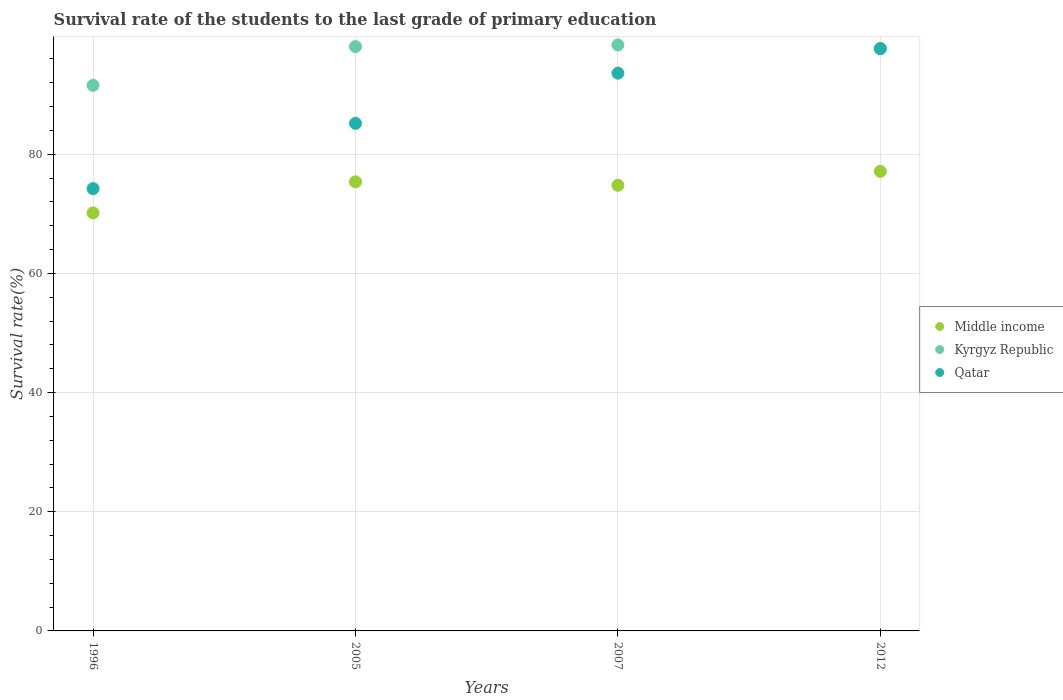How many different coloured dotlines are there?
Keep it short and to the point. 3. Is the number of dotlines equal to the number of legend labels?
Offer a terse response. Yes. What is the survival rate of the students in Kyrgyz Republic in 2012?
Provide a succinct answer. 97.74. Across all years, what is the maximum survival rate of the students in Kyrgyz Republic?
Provide a short and direct response. 98.35. Across all years, what is the minimum survival rate of the students in Qatar?
Your answer should be compact. 74.24. In which year was the survival rate of the students in Middle income minimum?
Your response must be concise. 1996. What is the total survival rate of the students in Middle income in the graph?
Provide a succinct answer. 297.47. What is the difference between the survival rate of the students in Kyrgyz Republic in 2007 and that in 2012?
Ensure brevity in your answer.  0.6. What is the difference between the survival rate of the students in Qatar in 2012 and the survival rate of the students in Kyrgyz Republic in 2007?
Your answer should be compact. -0.61. What is the average survival rate of the students in Qatar per year?
Provide a short and direct response. 87.7. In the year 2007, what is the difference between the survival rate of the students in Qatar and survival rate of the students in Kyrgyz Republic?
Provide a short and direct response. -4.73. In how many years, is the survival rate of the students in Qatar greater than 8 %?
Make the answer very short. 4. What is the ratio of the survival rate of the students in Kyrgyz Republic in 2005 to that in 2012?
Provide a succinct answer. 1. Is the difference between the survival rate of the students in Qatar in 1996 and 2005 greater than the difference between the survival rate of the students in Kyrgyz Republic in 1996 and 2005?
Your answer should be compact. No. What is the difference between the highest and the second highest survival rate of the students in Qatar?
Your response must be concise. 4.13. What is the difference between the highest and the lowest survival rate of the students in Kyrgyz Republic?
Make the answer very short. 6.78. In how many years, is the survival rate of the students in Kyrgyz Republic greater than the average survival rate of the students in Kyrgyz Republic taken over all years?
Your answer should be compact. 3. Does the survival rate of the students in Kyrgyz Republic monotonically increase over the years?
Provide a succinct answer. No. Is the survival rate of the students in Middle income strictly greater than the survival rate of the students in Kyrgyz Republic over the years?
Provide a succinct answer. No. How many dotlines are there?
Offer a very short reply. 3. How many years are there in the graph?
Give a very brief answer. 4. What is the difference between two consecutive major ticks on the Y-axis?
Provide a succinct answer. 20. Does the graph contain any zero values?
Make the answer very short. No. What is the title of the graph?
Provide a short and direct response. Survival rate of the students to the last grade of primary education. Does "Ireland" appear as one of the legend labels in the graph?
Keep it short and to the point. No. What is the label or title of the X-axis?
Keep it short and to the point. Years. What is the label or title of the Y-axis?
Make the answer very short. Survival rate(%). What is the Survival rate(%) in Middle income in 1996?
Make the answer very short. 70.16. What is the Survival rate(%) in Kyrgyz Republic in 1996?
Provide a short and direct response. 91.57. What is the Survival rate(%) of Qatar in 1996?
Ensure brevity in your answer.  74.24. What is the Survival rate(%) in Middle income in 2005?
Your response must be concise. 75.38. What is the Survival rate(%) in Kyrgyz Republic in 2005?
Make the answer very short. 98.08. What is the Survival rate(%) in Qatar in 2005?
Your answer should be compact. 85.19. What is the Survival rate(%) in Middle income in 2007?
Your answer should be compact. 74.79. What is the Survival rate(%) of Kyrgyz Republic in 2007?
Provide a succinct answer. 98.35. What is the Survival rate(%) in Qatar in 2007?
Your response must be concise. 93.61. What is the Survival rate(%) in Middle income in 2012?
Ensure brevity in your answer.  77.14. What is the Survival rate(%) in Kyrgyz Republic in 2012?
Your answer should be very brief. 97.74. What is the Survival rate(%) in Qatar in 2012?
Your answer should be compact. 97.74. Across all years, what is the maximum Survival rate(%) in Middle income?
Offer a very short reply. 77.14. Across all years, what is the maximum Survival rate(%) in Kyrgyz Republic?
Your response must be concise. 98.35. Across all years, what is the maximum Survival rate(%) in Qatar?
Offer a very short reply. 97.74. Across all years, what is the minimum Survival rate(%) of Middle income?
Your answer should be very brief. 70.16. Across all years, what is the minimum Survival rate(%) of Kyrgyz Republic?
Ensure brevity in your answer.  91.57. Across all years, what is the minimum Survival rate(%) in Qatar?
Offer a terse response. 74.24. What is the total Survival rate(%) in Middle income in the graph?
Keep it short and to the point. 297.47. What is the total Survival rate(%) of Kyrgyz Republic in the graph?
Your answer should be compact. 385.74. What is the total Survival rate(%) of Qatar in the graph?
Offer a very short reply. 350.78. What is the difference between the Survival rate(%) of Middle income in 1996 and that in 2005?
Make the answer very short. -5.21. What is the difference between the Survival rate(%) in Kyrgyz Republic in 1996 and that in 2005?
Keep it short and to the point. -6.51. What is the difference between the Survival rate(%) in Qatar in 1996 and that in 2005?
Give a very brief answer. -10.95. What is the difference between the Survival rate(%) of Middle income in 1996 and that in 2007?
Keep it short and to the point. -4.62. What is the difference between the Survival rate(%) of Kyrgyz Republic in 1996 and that in 2007?
Make the answer very short. -6.78. What is the difference between the Survival rate(%) in Qatar in 1996 and that in 2007?
Keep it short and to the point. -19.37. What is the difference between the Survival rate(%) of Middle income in 1996 and that in 2012?
Your response must be concise. -6.97. What is the difference between the Survival rate(%) of Kyrgyz Republic in 1996 and that in 2012?
Your answer should be very brief. -6.17. What is the difference between the Survival rate(%) of Qatar in 1996 and that in 2012?
Ensure brevity in your answer.  -23.5. What is the difference between the Survival rate(%) in Middle income in 2005 and that in 2007?
Provide a succinct answer. 0.59. What is the difference between the Survival rate(%) in Kyrgyz Republic in 2005 and that in 2007?
Keep it short and to the point. -0.27. What is the difference between the Survival rate(%) of Qatar in 2005 and that in 2007?
Offer a terse response. -8.42. What is the difference between the Survival rate(%) of Middle income in 2005 and that in 2012?
Make the answer very short. -1.76. What is the difference between the Survival rate(%) in Kyrgyz Republic in 2005 and that in 2012?
Provide a succinct answer. 0.34. What is the difference between the Survival rate(%) of Qatar in 2005 and that in 2012?
Ensure brevity in your answer.  -12.55. What is the difference between the Survival rate(%) in Middle income in 2007 and that in 2012?
Provide a short and direct response. -2.35. What is the difference between the Survival rate(%) in Kyrgyz Republic in 2007 and that in 2012?
Your answer should be compact. 0.6. What is the difference between the Survival rate(%) of Qatar in 2007 and that in 2012?
Your answer should be compact. -4.13. What is the difference between the Survival rate(%) of Middle income in 1996 and the Survival rate(%) of Kyrgyz Republic in 2005?
Provide a succinct answer. -27.92. What is the difference between the Survival rate(%) of Middle income in 1996 and the Survival rate(%) of Qatar in 2005?
Your answer should be very brief. -15.03. What is the difference between the Survival rate(%) of Kyrgyz Republic in 1996 and the Survival rate(%) of Qatar in 2005?
Your answer should be very brief. 6.38. What is the difference between the Survival rate(%) of Middle income in 1996 and the Survival rate(%) of Kyrgyz Republic in 2007?
Your answer should be very brief. -28.18. What is the difference between the Survival rate(%) in Middle income in 1996 and the Survival rate(%) in Qatar in 2007?
Keep it short and to the point. -23.45. What is the difference between the Survival rate(%) of Kyrgyz Republic in 1996 and the Survival rate(%) of Qatar in 2007?
Offer a very short reply. -2.04. What is the difference between the Survival rate(%) in Middle income in 1996 and the Survival rate(%) in Kyrgyz Republic in 2012?
Your answer should be very brief. -27.58. What is the difference between the Survival rate(%) in Middle income in 1996 and the Survival rate(%) in Qatar in 2012?
Make the answer very short. -27.57. What is the difference between the Survival rate(%) in Kyrgyz Republic in 1996 and the Survival rate(%) in Qatar in 2012?
Make the answer very short. -6.17. What is the difference between the Survival rate(%) in Middle income in 2005 and the Survival rate(%) in Kyrgyz Republic in 2007?
Offer a terse response. -22.97. What is the difference between the Survival rate(%) of Middle income in 2005 and the Survival rate(%) of Qatar in 2007?
Give a very brief answer. -18.24. What is the difference between the Survival rate(%) of Kyrgyz Republic in 2005 and the Survival rate(%) of Qatar in 2007?
Your answer should be very brief. 4.47. What is the difference between the Survival rate(%) of Middle income in 2005 and the Survival rate(%) of Kyrgyz Republic in 2012?
Your answer should be compact. -22.37. What is the difference between the Survival rate(%) of Middle income in 2005 and the Survival rate(%) of Qatar in 2012?
Your answer should be very brief. -22.36. What is the difference between the Survival rate(%) of Kyrgyz Republic in 2005 and the Survival rate(%) of Qatar in 2012?
Make the answer very short. 0.34. What is the difference between the Survival rate(%) in Middle income in 2007 and the Survival rate(%) in Kyrgyz Republic in 2012?
Offer a terse response. -22.96. What is the difference between the Survival rate(%) in Middle income in 2007 and the Survival rate(%) in Qatar in 2012?
Ensure brevity in your answer.  -22.95. What is the difference between the Survival rate(%) in Kyrgyz Republic in 2007 and the Survival rate(%) in Qatar in 2012?
Your response must be concise. 0.61. What is the average Survival rate(%) in Middle income per year?
Offer a terse response. 74.37. What is the average Survival rate(%) of Kyrgyz Republic per year?
Offer a very short reply. 96.44. What is the average Survival rate(%) of Qatar per year?
Your response must be concise. 87.7. In the year 1996, what is the difference between the Survival rate(%) in Middle income and Survival rate(%) in Kyrgyz Republic?
Provide a succinct answer. -21.41. In the year 1996, what is the difference between the Survival rate(%) in Middle income and Survival rate(%) in Qatar?
Provide a succinct answer. -4.07. In the year 1996, what is the difference between the Survival rate(%) of Kyrgyz Republic and Survival rate(%) of Qatar?
Ensure brevity in your answer.  17.33. In the year 2005, what is the difference between the Survival rate(%) in Middle income and Survival rate(%) in Kyrgyz Republic?
Your answer should be very brief. -22.7. In the year 2005, what is the difference between the Survival rate(%) of Middle income and Survival rate(%) of Qatar?
Offer a terse response. -9.82. In the year 2005, what is the difference between the Survival rate(%) of Kyrgyz Republic and Survival rate(%) of Qatar?
Keep it short and to the point. 12.89. In the year 2007, what is the difference between the Survival rate(%) of Middle income and Survival rate(%) of Kyrgyz Republic?
Your answer should be compact. -23.56. In the year 2007, what is the difference between the Survival rate(%) of Middle income and Survival rate(%) of Qatar?
Your answer should be very brief. -18.83. In the year 2007, what is the difference between the Survival rate(%) of Kyrgyz Republic and Survival rate(%) of Qatar?
Your answer should be very brief. 4.73. In the year 2012, what is the difference between the Survival rate(%) of Middle income and Survival rate(%) of Kyrgyz Republic?
Ensure brevity in your answer.  -20.6. In the year 2012, what is the difference between the Survival rate(%) in Middle income and Survival rate(%) in Qatar?
Keep it short and to the point. -20.6. In the year 2012, what is the difference between the Survival rate(%) in Kyrgyz Republic and Survival rate(%) in Qatar?
Make the answer very short. 0. What is the ratio of the Survival rate(%) in Middle income in 1996 to that in 2005?
Ensure brevity in your answer.  0.93. What is the ratio of the Survival rate(%) of Kyrgyz Republic in 1996 to that in 2005?
Provide a succinct answer. 0.93. What is the ratio of the Survival rate(%) of Qatar in 1996 to that in 2005?
Offer a terse response. 0.87. What is the ratio of the Survival rate(%) in Middle income in 1996 to that in 2007?
Your answer should be compact. 0.94. What is the ratio of the Survival rate(%) in Kyrgyz Republic in 1996 to that in 2007?
Keep it short and to the point. 0.93. What is the ratio of the Survival rate(%) in Qatar in 1996 to that in 2007?
Provide a short and direct response. 0.79. What is the ratio of the Survival rate(%) of Middle income in 1996 to that in 2012?
Your answer should be very brief. 0.91. What is the ratio of the Survival rate(%) of Kyrgyz Republic in 1996 to that in 2012?
Your answer should be very brief. 0.94. What is the ratio of the Survival rate(%) of Qatar in 1996 to that in 2012?
Offer a very short reply. 0.76. What is the ratio of the Survival rate(%) of Middle income in 2005 to that in 2007?
Ensure brevity in your answer.  1.01. What is the ratio of the Survival rate(%) in Kyrgyz Republic in 2005 to that in 2007?
Keep it short and to the point. 1. What is the ratio of the Survival rate(%) in Qatar in 2005 to that in 2007?
Ensure brevity in your answer.  0.91. What is the ratio of the Survival rate(%) in Middle income in 2005 to that in 2012?
Offer a very short reply. 0.98. What is the ratio of the Survival rate(%) in Qatar in 2005 to that in 2012?
Ensure brevity in your answer.  0.87. What is the ratio of the Survival rate(%) in Middle income in 2007 to that in 2012?
Provide a succinct answer. 0.97. What is the ratio of the Survival rate(%) of Qatar in 2007 to that in 2012?
Provide a succinct answer. 0.96. What is the difference between the highest and the second highest Survival rate(%) in Middle income?
Make the answer very short. 1.76. What is the difference between the highest and the second highest Survival rate(%) of Kyrgyz Republic?
Provide a short and direct response. 0.27. What is the difference between the highest and the second highest Survival rate(%) in Qatar?
Offer a very short reply. 4.13. What is the difference between the highest and the lowest Survival rate(%) in Middle income?
Provide a short and direct response. 6.97. What is the difference between the highest and the lowest Survival rate(%) of Kyrgyz Republic?
Offer a very short reply. 6.78. What is the difference between the highest and the lowest Survival rate(%) in Qatar?
Give a very brief answer. 23.5. 